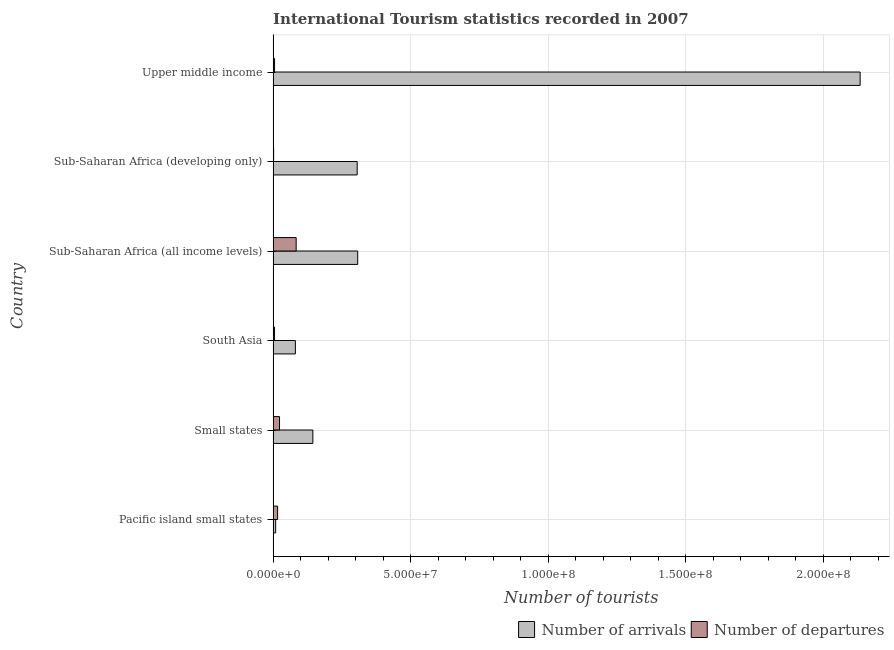How many bars are there on the 4th tick from the top?
Make the answer very short. 2. How many bars are there on the 1st tick from the bottom?
Make the answer very short. 2. What is the label of the 3rd group of bars from the top?
Your answer should be very brief. Sub-Saharan Africa (all income levels). What is the number of tourist arrivals in Sub-Saharan Africa (developing only)?
Your answer should be compact. 3.05e+07. Across all countries, what is the maximum number of tourist departures?
Your response must be concise. 8.37e+06. Across all countries, what is the minimum number of tourist departures?
Make the answer very short. 1.81e+05. In which country was the number of tourist arrivals maximum?
Your answer should be compact. Upper middle income. In which country was the number of tourist departures minimum?
Your answer should be compact. Sub-Saharan Africa (developing only). What is the total number of tourist arrivals in the graph?
Provide a short and direct response. 2.98e+08. What is the difference between the number of tourist departures in Small states and that in Sub-Saharan Africa (developing only)?
Your answer should be compact. 2.15e+06. What is the difference between the number of tourist arrivals in South Asia and the number of tourist departures in Sub-Saharan Africa (all income levels)?
Your answer should be very brief. -2.83e+05. What is the average number of tourist arrivals per country?
Your response must be concise. 4.97e+07. What is the difference between the number of tourist arrivals and number of tourist departures in Upper middle income?
Your response must be concise. 2.13e+08. What is the ratio of the number of tourist departures in Pacific island small states to that in Upper middle income?
Make the answer very short. 3.1. Is the number of tourist departures in Small states less than that in Sub-Saharan Africa (developing only)?
Provide a short and direct response. No. What is the difference between the highest and the second highest number of tourist arrivals?
Your response must be concise. 1.83e+08. What is the difference between the highest and the lowest number of tourist departures?
Your answer should be compact. 8.19e+06. What does the 1st bar from the top in Small states represents?
Offer a very short reply. Number of departures. What does the 1st bar from the bottom in South Asia represents?
Your answer should be very brief. Number of arrivals. Does the graph contain grids?
Provide a succinct answer. Yes. How many legend labels are there?
Give a very brief answer. 2. How are the legend labels stacked?
Offer a terse response. Horizontal. What is the title of the graph?
Provide a succinct answer. International Tourism statistics recorded in 2007. Does "International Visitors" appear as one of the legend labels in the graph?
Ensure brevity in your answer.  No. What is the label or title of the X-axis?
Offer a terse response. Number of tourists. What is the label or title of the Y-axis?
Ensure brevity in your answer.  Country. What is the Number of tourists of Number of arrivals in Pacific island small states?
Your answer should be very brief. 9.20e+05. What is the Number of tourists in Number of departures in Pacific island small states?
Your answer should be compact. 1.63e+06. What is the Number of tourists in Number of arrivals in Small states?
Provide a succinct answer. 1.44e+07. What is the Number of tourists in Number of departures in Small states?
Keep it short and to the point. 2.33e+06. What is the Number of tourists of Number of arrivals in South Asia?
Offer a terse response. 8.09e+06. What is the Number of tourists in Number of departures in South Asia?
Provide a succinct answer. 5.17e+05. What is the Number of tourists in Number of arrivals in Sub-Saharan Africa (all income levels)?
Ensure brevity in your answer.  3.07e+07. What is the Number of tourists in Number of departures in Sub-Saharan Africa (all income levels)?
Your response must be concise. 8.37e+06. What is the Number of tourists in Number of arrivals in Sub-Saharan Africa (developing only)?
Your answer should be very brief. 3.05e+07. What is the Number of tourists in Number of departures in Sub-Saharan Africa (developing only)?
Make the answer very short. 1.81e+05. What is the Number of tourists of Number of arrivals in Upper middle income?
Offer a terse response. 2.13e+08. What is the Number of tourists in Number of departures in Upper middle income?
Offer a very short reply. 5.26e+05. Across all countries, what is the maximum Number of tourists of Number of arrivals?
Give a very brief answer. 2.13e+08. Across all countries, what is the maximum Number of tourists in Number of departures?
Give a very brief answer. 8.37e+06. Across all countries, what is the minimum Number of tourists in Number of arrivals?
Your response must be concise. 9.20e+05. Across all countries, what is the minimum Number of tourists of Number of departures?
Make the answer very short. 1.81e+05. What is the total Number of tourists of Number of arrivals in the graph?
Provide a short and direct response. 2.98e+08. What is the total Number of tourists of Number of departures in the graph?
Offer a terse response. 1.36e+07. What is the difference between the Number of tourists of Number of arrivals in Pacific island small states and that in Small states?
Keep it short and to the point. -1.35e+07. What is the difference between the Number of tourists of Number of departures in Pacific island small states and that in Small states?
Your answer should be very brief. -6.96e+05. What is the difference between the Number of tourists of Number of arrivals in Pacific island small states and that in South Asia?
Give a very brief answer. -7.17e+06. What is the difference between the Number of tourists in Number of departures in Pacific island small states and that in South Asia?
Keep it short and to the point. 1.11e+06. What is the difference between the Number of tourists of Number of arrivals in Pacific island small states and that in Sub-Saharan Africa (all income levels)?
Your response must be concise. -2.98e+07. What is the difference between the Number of tourists in Number of departures in Pacific island small states and that in Sub-Saharan Africa (all income levels)?
Give a very brief answer. -6.74e+06. What is the difference between the Number of tourists of Number of arrivals in Pacific island small states and that in Sub-Saharan Africa (developing only)?
Offer a very short reply. -2.96e+07. What is the difference between the Number of tourists in Number of departures in Pacific island small states and that in Sub-Saharan Africa (developing only)?
Provide a short and direct response. 1.45e+06. What is the difference between the Number of tourists in Number of arrivals in Pacific island small states and that in Upper middle income?
Provide a short and direct response. -2.12e+08. What is the difference between the Number of tourists in Number of departures in Pacific island small states and that in Upper middle income?
Offer a terse response. 1.10e+06. What is the difference between the Number of tourists of Number of arrivals in Small states and that in South Asia?
Your answer should be compact. 6.35e+06. What is the difference between the Number of tourists of Number of departures in Small states and that in South Asia?
Offer a very short reply. 1.81e+06. What is the difference between the Number of tourists of Number of arrivals in Small states and that in Sub-Saharan Africa (all income levels)?
Give a very brief answer. -1.63e+07. What is the difference between the Number of tourists in Number of departures in Small states and that in Sub-Saharan Africa (all income levels)?
Make the answer very short. -6.04e+06. What is the difference between the Number of tourists of Number of arrivals in Small states and that in Sub-Saharan Africa (developing only)?
Ensure brevity in your answer.  -1.61e+07. What is the difference between the Number of tourists of Number of departures in Small states and that in Sub-Saharan Africa (developing only)?
Keep it short and to the point. 2.15e+06. What is the difference between the Number of tourists of Number of arrivals in Small states and that in Upper middle income?
Provide a short and direct response. -1.99e+08. What is the difference between the Number of tourists of Number of departures in Small states and that in Upper middle income?
Provide a short and direct response. 1.80e+06. What is the difference between the Number of tourists in Number of arrivals in South Asia and that in Sub-Saharan Africa (all income levels)?
Ensure brevity in your answer.  -2.27e+07. What is the difference between the Number of tourists in Number of departures in South Asia and that in Sub-Saharan Africa (all income levels)?
Your answer should be very brief. -7.85e+06. What is the difference between the Number of tourists in Number of arrivals in South Asia and that in Sub-Saharan Africa (developing only)?
Offer a very short reply. -2.25e+07. What is the difference between the Number of tourists of Number of departures in South Asia and that in Sub-Saharan Africa (developing only)?
Keep it short and to the point. 3.36e+05. What is the difference between the Number of tourists in Number of arrivals in South Asia and that in Upper middle income?
Provide a short and direct response. -2.05e+08. What is the difference between the Number of tourists in Number of departures in South Asia and that in Upper middle income?
Your answer should be compact. -9000. What is the difference between the Number of tourists of Number of arrivals in Sub-Saharan Africa (all income levels) and that in Sub-Saharan Africa (developing only)?
Your answer should be compact. 1.95e+05. What is the difference between the Number of tourists of Number of departures in Sub-Saharan Africa (all income levels) and that in Sub-Saharan Africa (developing only)?
Provide a succinct answer. 8.19e+06. What is the difference between the Number of tourists in Number of arrivals in Sub-Saharan Africa (all income levels) and that in Upper middle income?
Your answer should be compact. -1.83e+08. What is the difference between the Number of tourists of Number of departures in Sub-Saharan Africa (all income levels) and that in Upper middle income?
Your answer should be compact. 7.84e+06. What is the difference between the Number of tourists of Number of arrivals in Sub-Saharan Africa (developing only) and that in Upper middle income?
Provide a short and direct response. -1.83e+08. What is the difference between the Number of tourists of Number of departures in Sub-Saharan Africa (developing only) and that in Upper middle income?
Offer a very short reply. -3.45e+05. What is the difference between the Number of tourists in Number of arrivals in Pacific island small states and the Number of tourists in Number of departures in Small states?
Give a very brief answer. -1.41e+06. What is the difference between the Number of tourists in Number of arrivals in Pacific island small states and the Number of tourists in Number of departures in South Asia?
Offer a terse response. 4.03e+05. What is the difference between the Number of tourists of Number of arrivals in Pacific island small states and the Number of tourists of Number of departures in Sub-Saharan Africa (all income levels)?
Offer a very short reply. -7.45e+06. What is the difference between the Number of tourists of Number of arrivals in Pacific island small states and the Number of tourists of Number of departures in Sub-Saharan Africa (developing only)?
Ensure brevity in your answer.  7.39e+05. What is the difference between the Number of tourists of Number of arrivals in Pacific island small states and the Number of tourists of Number of departures in Upper middle income?
Ensure brevity in your answer.  3.94e+05. What is the difference between the Number of tourists in Number of arrivals in Small states and the Number of tourists in Number of departures in South Asia?
Ensure brevity in your answer.  1.39e+07. What is the difference between the Number of tourists of Number of arrivals in Small states and the Number of tourists of Number of departures in Sub-Saharan Africa (all income levels)?
Provide a short and direct response. 6.07e+06. What is the difference between the Number of tourists of Number of arrivals in Small states and the Number of tourists of Number of departures in Sub-Saharan Africa (developing only)?
Provide a short and direct response. 1.43e+07. What is the difference between the Number of tourists of Number of arrivals in Small states and the Number of tourists of Number of departures in Upper middle income?
Make the answer very short. 1.39e+07. What is the difference between the Number of tourists of Number of arrivals in South Asia and the Number of tourists of Number of departures in Sub-Saharan Africa (all income levels)?
Offer a terse response. -2.83e+05. What is the difference between the Number of tourists of Number of arrivals in South Asia and the Number of tourists of Number of departures in Sub-Saharan Africa (developing only)?
Your answer should be compact. 7.91e+06. What is the difference between the Number of tourists of Number of arrivals in South Asia and the Number of tourists of Number of departures in Upper middle income?
Keep it short and to the point. 7.56e+06. What is the difference between the Number of tourists in Number of arrivals in Sub-Saharan Africa (all income levels) and the Number of tourists in Number of departures in Sub-Saharan Africa (developing only)?
Offer a very short reply. 3.06e+07. What is the difference between the Number of tourists of Number of arrivals in Sub-Saharan Africa (all income levels) and the Number of tourists of Number of departures in Upper middle income?
Provide a short and direct response. 3.02e+07. What is the difference between the Number of tourists in Number of arrivals in Sub-Saharan Africa (developing only) and the Number of tourists in Number of departures in Upper middle income?
Provide a short and direct response. 3.00e+07. What is the average Number of tourists of Number of arrivals per country?
Provide a succinct answer. 4.97e+07. What is the average Number of tourists in Number of departures per country?
Provide a succinct answer. 2.26e+06. What is the difference between the Number of tourists of Number of arrivals and Number of tourists of Number of departures in Pacific island small states?
Keep it short and to the point. -7.11e+05. What is the difference between the Number of tourists in Number of arrivals and Number of tourists in Number of departures in Small states?
Make the answer very short. 1.21e+07. What is the difference between the Number of tourists of Number of arrivals and Number of tourists of Number of departures in South Asia?
Keep it short and to the point. 7.57e+06. What is the difference between the Number of tourists in Number of arrivals and Number of tourists in Number of departures in Sub-Saharan Africa (all income levels)?
Your answer should be compact. 2.24e+07. What is the difference between the Number of tourists in Number of arrivals and Number of tourists in Number of departures in Sub-Saharan Africa (developing only)?
Keep it short and to the point. 3.04e+07. What is the difference between the Number of tourists of Number of arrivals and Number of tourists of Number of departures in Upper middle income?
Your answer should be very brief. 2.13e+08. What is the ratio of the Number of tourists of Number of arrivals in Pacific island small states to that in Small states?
Ensure brevity in your answer.  0.06. What is the ratio of the Number of tourists of Number of departures in Pacific island small states to that in Small states?
Offer a very short reply. 0.7. What is the ratio of the Number of tourists of Number of arrivals in Pacific island small states to that in South Asia?
Provide a succinct answer. 0.11. What is the ratio of the Number of tourists in Number of departures in Pacific island small states to that in South Asia?
Your answer should be very brief. 3.15. What is the ratio of the Number of tourists in Number of arrivals in Pacific island small states to that in Sub-Saharan Africa (all income levels)?
Make the answer very short. 0.03. What is the ratio of the Number of tourists in Number of departures in Pacific island small states to that in Sub-Saharan Africa (all income levels)?
Offer a very short reply. 0.19. What is the ratio of the Number of tourists in Number of arrivals in Pacific island small states to that in Sub-Saharan Africa (developing only)?
Provide a succinct answer. 0.03. What is the ratio of the Number of tourists in Number of departures in Pacific island small states to that in Sub-Saharan Africa (developing only)?
Provide a short and direct response. 9.01. What is the ratio of the Number of tourists in Number of arrivals in Pacific island small states to that in Upper middle income?
Ensure brevity in your answer.  0. What is the ratio of the Number of tourists in Number of departures in Pacific island small states to that in Upper middle income?
Your response must be concise. 3.1. What is the ratio of the Number of tourists of Number of arrivals in Small states to that in South Asia?
Ensure brevity in your answer.  1.79. What is the ratio of the Number of tourists in Number of departures in Small states to that in South Asia?
Ensure brevity in your answer.  4.5. What is the ratio of the Number of tourists of Number of arrivals in Small states to that in Sub-Saharan Africa (all income levels)?
Provide a succinct answer. 0.47. What is the ratio of the Number of tourists in Number of departures in Small states to that in Sub-Saharan Africa (all income levels)?
Your answer should be compact. 0.28. What is the ratio of the Number of tourists in Number of arrivals in Small states to that in Sub-Saharan Africa (developing only)?
Your response must be concise. 0.47. What is the ratio of the Number of tourists in Number of departures in Small states to that in Sub-Saharan Africa (developing only)?
Your answer should be compact. 12.86. What is the ratio of the Number of tourists of Number of arrivals in Small states to that in Upper middle income?
Your answer should be compact. 0.07. What is the ratio of the Number of tourists of Number of departures in Small states to that in Upper middle income?
Provide a succinct answer. 4.42. What is the ratio of the Number of tourists of Number of arrivals in South Asia to that in Sub-Saharan Africa (all income levels)?
Your response must be concise. 0.26. What is the ratio of the Number of tourists in Number of departures in South Asia to that in Sub-Saharan Africa (all income levels)?
Your answer should be compact. 0.06. What is the ratio of the Number of tourists in Number of arrivals in South Asia to that in Sub-Saharan Africa (developing only)?
Make the answer very short. 0.26. What is the ratio of the Number of tourists of Number of departures in South Asia to that in Sub-Saharan Africa (developing only)?
Keep it short and to the point. 2.86. What is the ratio of the Number of tourists of Number of arrivals in South Asia to that in Upper middle income?
Provide a short and direct response. 0.04. What is the ratio of the Number of tourists in Number of departures in South Asia to that in Upper middle income?
Your answer should be very brief. 0.98. What is the ratio of the Number of tourists in Number of arrivals in Sub-Saharan Africa (all income levels) to that in Sub-Saharan Africa (developing only)?
Your answer should be compact. 1.01. What is the ratio of the Number of tourists of Number of departures in Sub-Saharan Africa (all income levels) to that in Sub-Saharan Africa (developing only)?
Make the answer very short. 46.25. What is the ratio of the Number of tourists in Number of arrivals in Sub-Saharan Africa (all income levels) to that in Upper middle income?
Ensure brevity in your answer.  0.14. What is the ratio of the Number of tourists of Number of departures in Sub-Saharan Africa (all income levels) to that in Upper middle income?
Ensure brevity in your answer.  15.91. What is the ratio of the Number of tourists in Number of arrivals in Sub-Saharan Africa (developing only) to that in Upper middle income?
Your response must be concise. 0.14. What is the ratio of the Number of tourists of Number of departures in Sub-Saharan Africa (developing only) to that in Upper middle income?
Your answer should be compact. 0.34. What is the difference between the highest and the second highest Number of tourists in Number of arrivals?
Ensure brevity in your answer.  1.83e+08. What is the difference between the highest and the second highest Number of tourists in Number of departures?
Your response must be concise. 6.04e+06. What is the difference between the highest and the lowest Number of tourists of Number of arrivals?
Provide a short and direct response. 2.12e+08. What is the difference between the highest and the lowest Number of tourists in Number of departures?
Give a very brief answer. 8.19e+06. 